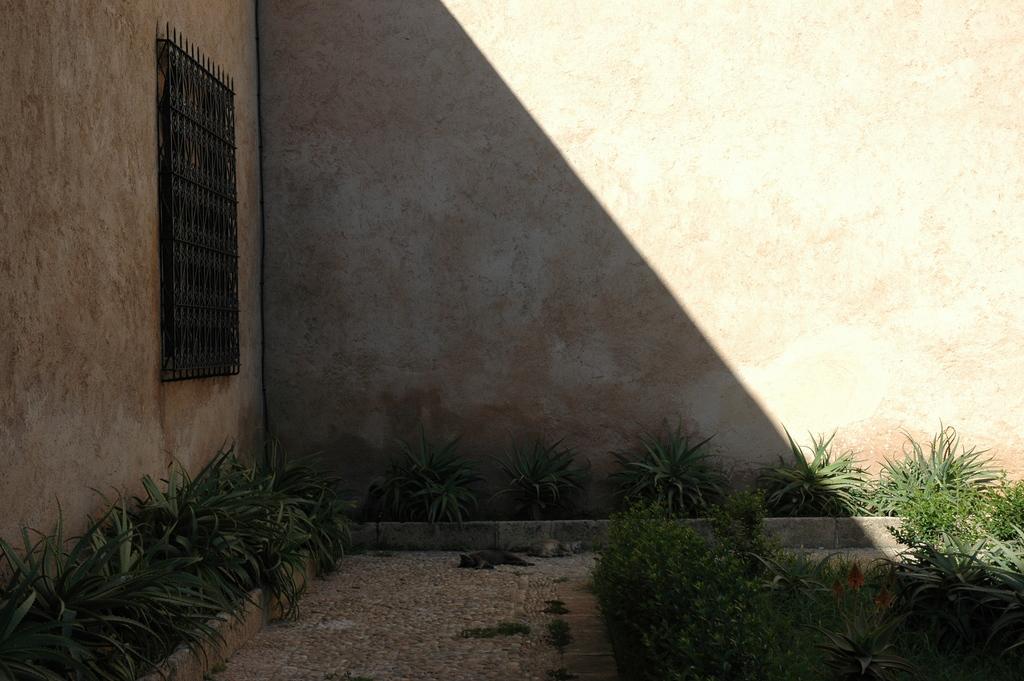Describe this image in one or two sentences. In this image we can see the walls of the house. There are many plants in the image. There is a walkway in the image. We can see a window and metallic object in the image. 